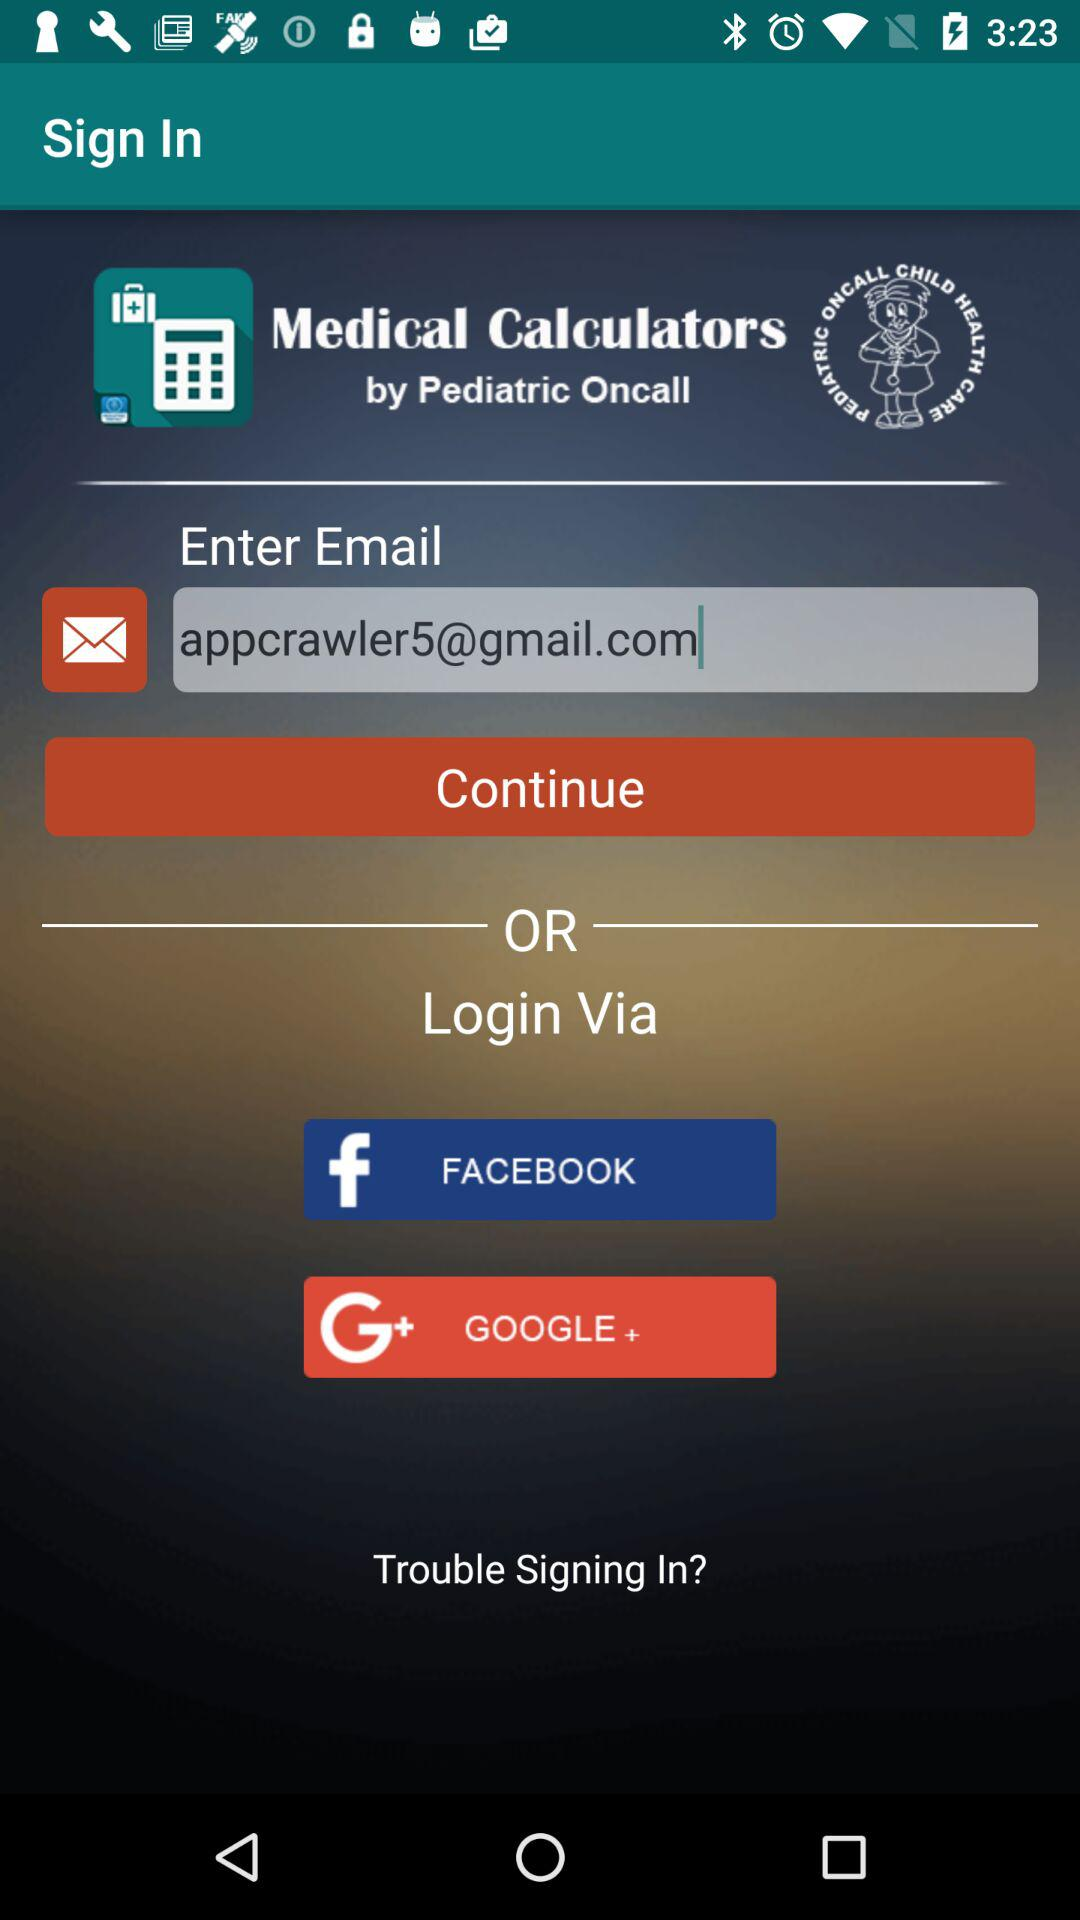What is the app name? The app name is "Medical Calculators". 